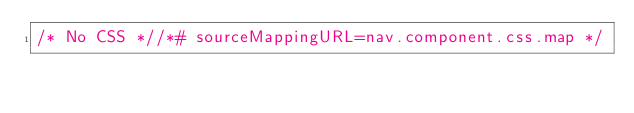Convert code to text. <code><loc_0><loc_0><loc_500><loc_500><_CSS_>/* No CSS *//*# sourceMappingURL=nav.component.css.map */</code> 